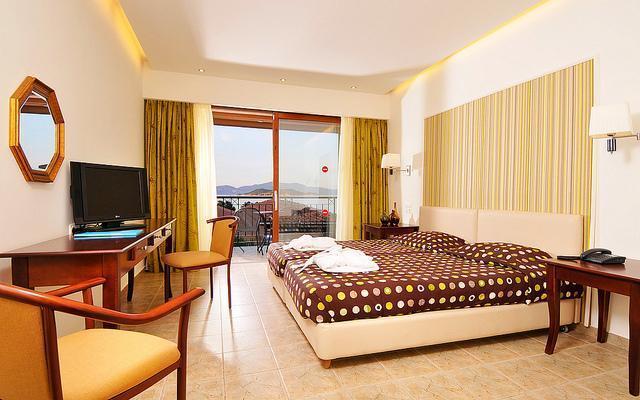How many beds are there?
Give a very brief answer. 2. How many chairs are there?
Give a very brief answer. 2. 